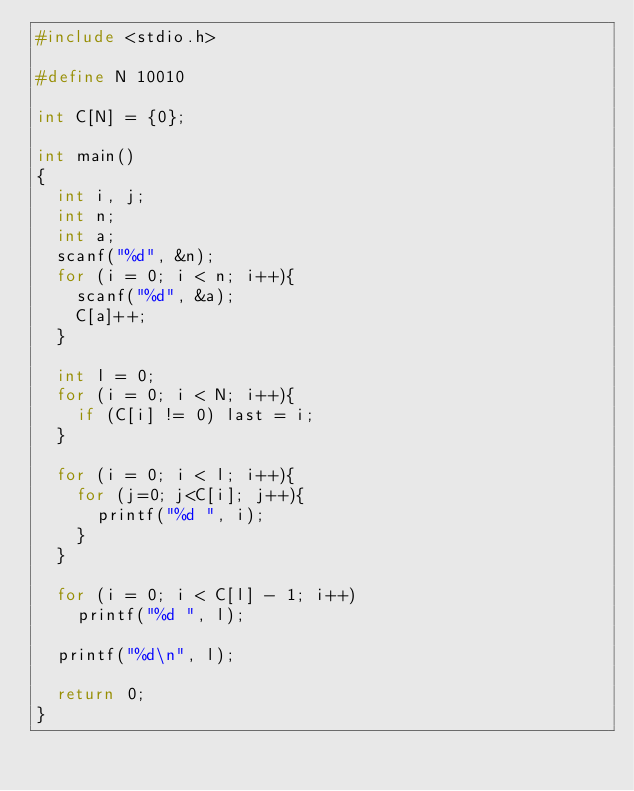<code> <loc_0><loc_0><loc_500><loc_500><_C_>#include <stdio.h>
 
#define N 10010
  
int C[N] = {0};
  
int main()
{
  int i, j;
  int n;
  int a;
  scanf("%d", &n);
  for (i = 0; i < n; i++){
    scanf("%d", &a);
    C[a]++;
  }
      
  int l = 0;
  for (i = 0; i < N; i++){
    if (C[i] != 0) last = i;
  }
      
  for (i = 0; i < l; i++){
    for (j=0; j<C[i]; j++){
      printf("%d ", i);
    }
  }
 
  for (i = 0; i < C[l] - 1; i++)
    printf("%d ", l);
  
  printf("%d\n", l);
      
  return 0;
}</code> 